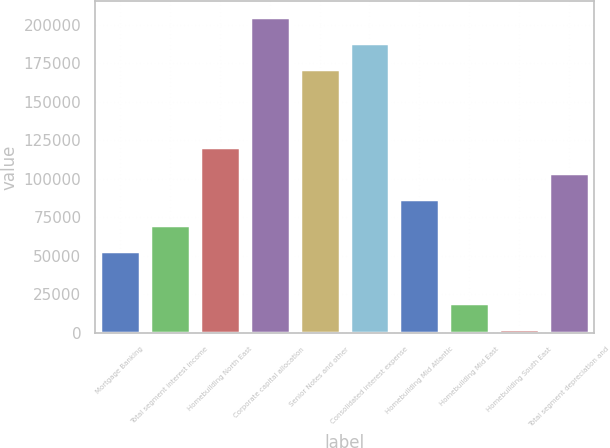Convert chart to OTSL. <chart><loc_0><loc_0><loc_500><loc_500><bar_chart><fcel>Mortgage Banking<fcel>Total segment interest income<fcel>Homebuilding North East<fcel>Corporate capital allocation<fcel>Senior Notes and other<fcel>Consolidated interest expense<fcel>Homebuilding Mid Atlantic<fcel>Homebuilding Mid East<fcel>Homebuilding South East<fcel>Total segment depreciation and<nl><fcel>52884.7<fcel>69782.6<fcel>120476<fcel>204966<fcel>171170<fcel>188068<fcel>86680.5<fcel>19088.9<fcel>2191<fcel>103578<nl></chart> 